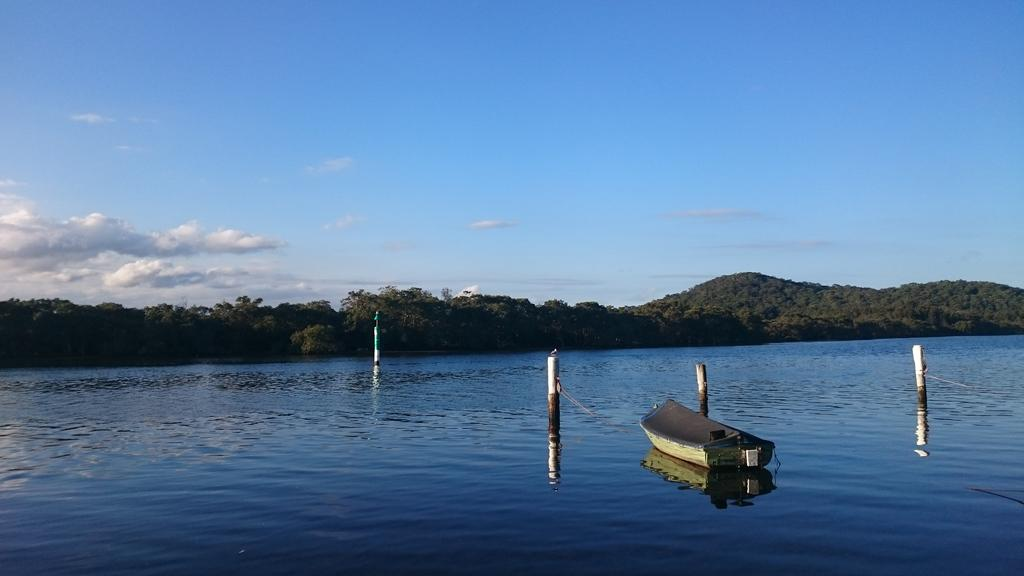What is the main subject of the image? The main subject of the image is a boat. Where is the boat located? The boat is on the water. What can be seen in the water besides the boat? There are poles in the water. What is the color of the water? The water is blue. What can be seen in the background of the image? There are trees and mountains visible in the background. What is the color of the sky in the image? The sky is blue and white. How many servants are attending to the flock of animals in the image? There are no servants or animals present in the image; it features a boat on the water with poles, trees, mountains, and a blue and white sky in the background. 